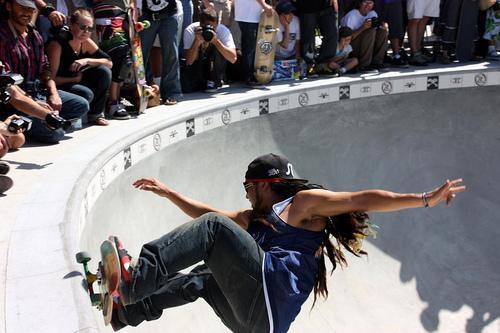How many people are skateboarding?
Give a very brief answer. 1. How many people can you see?
Give a very brief answer. 7. 